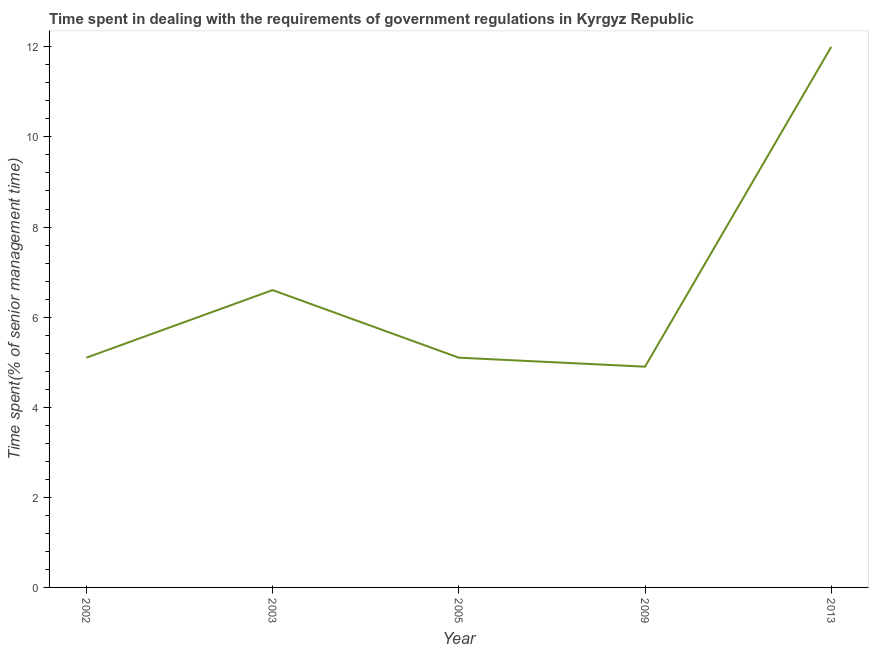What is the time spent in dealing with government regulations in 2002?
Ensure brevity in your answer.  5.1. Across all years, what is the maximum time spent in dealing with government regulations?
Make the answer very short. 12. Across all years, what is the minimum time spent in dealing with government regulations?
Give a very brief answer. 4.9. In which year was the time spent in dealing with government regulations maximum?
Provide a short and direct response. 2013. In which year was the time spent in dealing with government regulations minimum?
Your response must be concise. 2009. What is the sum of the time spent in dealing with government regulations?
Make the answer very short. 33.7. What is the difference between the time spent in dealing with government regulations in 2003 and 2009?
Your response must be concise. 1.7. What is the average time spent in dealing with government regulations per year?
Make the answer very short. 6.74. In how many years, is the time spent in dealing with government regulations greater than 9.6 %?
Your response must be concise. 1. What is the ratio of the time spent in dealing with government regulations in 2002 to that in 2013?
Offer a very short reply. 0.42. Is the time spent in dealing with government regulations in 2003 less than that in 2009?
Provide a short and direct response. No. Is the difference between the time spent in dealing with government regulations in 2003 and 2005 greater than the difference between any two years?
Your response must be concise. No. What is the difference between the highest and the second highest time spent in dealing with government regulations?
Provide a succinct answer. 5.4. Is the sum of the time spent in dealing with government regulations in 2003 and 2005 greater than the maximum time spent in dealing with government regulations across all years?
Your answer should be very brief. No. What is the difference between the highest and the lowest time spent in dealing with government regulations?
Your response must be concise. 7.1. How many lines are there?
Your answer should be compact. 1. How many years are there in the graph?
Provide a short and direct response. 5. What is the difference between two consecutive major ticks on the Y-axis?
Make the answer very short. 2. Does the graph contain any zero values?
Your response must be concise. No. What is the title of the graph?
Offer a very short reply. Time spent in dealing with the requirements of government regulations in Kyrgyz Republic. What is the label or title of the X-axis?
Give a very brief answer. Year. What is the label or title of the Y-axis?
Give a very brief answer. Time spent(% of senior management time). What is the Time spent(% of senior management time) of 2002?
Your response must be concise. 5.1. What is the difference between the Time spent(% of senior management time) in 2002 and 2005?
Provide a succinct answer. 0. What is the difference between the Time spent(% of senior management time) in 2002 and 2009?
Your answer should be compact. 0.2. What is the difference between the Time spent(% of senior management time) in 2003 and 2005?
Your answer should be compact. 1.5. What is the difference between the Time spent(% of senior management time) in 2003 and 2009?
Make the answer very short. 1.7. What is the difference between the Time spent(% of senior management time) in 2005 and 2009?
Offer a very short reply. 0.2. What is the difference between the Time spent(% of senior management time) in 2005 and 2013?
Keep it short and to the point. -6.9. What is the difference between the Time spent(% of senior management time) in 2009 and 2013?
Give a very brief answer. -7.1. What is the ratio of the Time spent(% of senior management time) in 2002 to that in 2003?
Your response must be concise. 0.77. What is the ratio of the Time spent(% of senior management time) in 2002 to that in 2005?
Provide a short and direct response. 1. What is the ratio of the Time spent(% of senior management time) in 2002 to that in 2009?
Your answer should be compact. 1.04. What is the ratio of the Time spent(% of senior management time) in 2002 to that in 2013?
Provide a succinct answer. 0.42. What is the ratio of the Time spent(% of senior management time) in 2003 to that in 2005?
Your answer should be very brief. 1.29. What is the ratio of the Time spent(% of senior management time) in 2003 to that in 2009?
Keep it short and to the point. 1.35. What is the ratio of the Time spent(% of senior management time) in 2003 to that in 2013?
Your response must be concise. 0.55. What is the ratio of the Time spent(% of senior management time) in 2005 to that in 2009?
Give a very brief answer. 1.04. What is the ratio of the Time spent(% of senior management time) in 2005 to that in 2013?
Ensure brevity in your answer.  0.42. What is the ratio of the Time spent(% of senior management time) in 2009 to that in 2013?
Your answer should be compact. 0.41. 